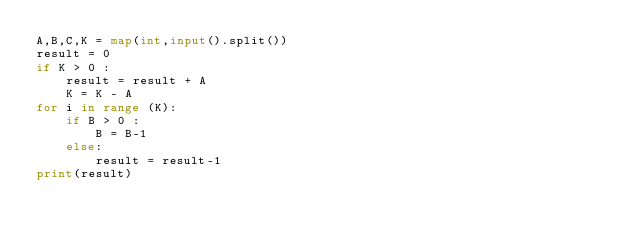<code> <loc_0><loc_0><loc_500><loc_500><_Python_>A,B,C,K = map(int,input().split())
result = 0
if K > 0 :
    result = result + A
    K = K - A
for i in range (K):
    if B > 0 :
        B = B-1
    else:
        result = result-1
print(result)</code> 